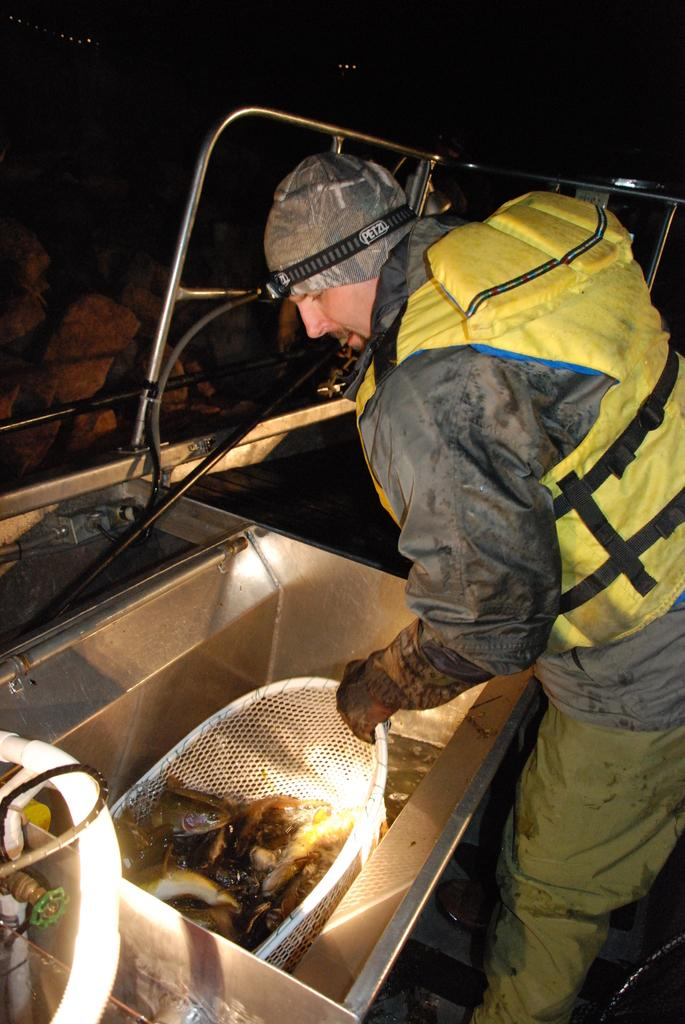Who is the main subject in the image? There is a man in the image. What is the man doing in the image? The man is standing in the image. What type of clothing is the man wearing? The man is wearing a jacket, gloves, pants, and a cap. What is the man holding in the image? The man is holding a basket in the image. What is inside the basket? There are items in the basket. What direction is the marble rolling in the image? There is no marble present in the image, so it cannot be determined which direction it would roll. 